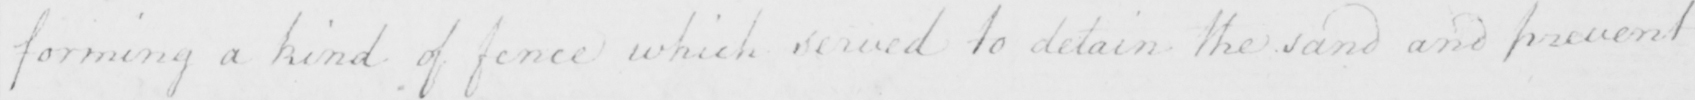Please transcribe the handwritten text in this image. forming a kind of fence which served to detain the sand and prevent 